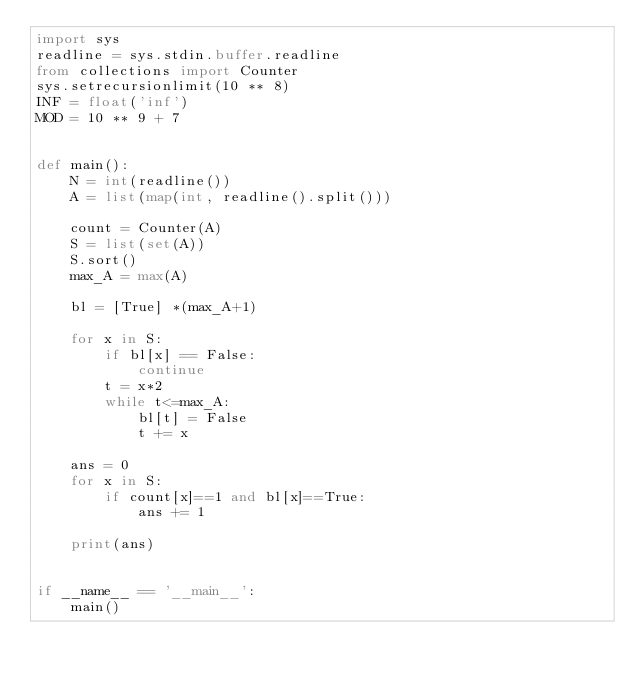<code> <loc_0><loc_0><loc_500><loc_500><_Python_>import sys
readline = sys.stdin.buffer.readline
from collections import Counter
sys.setrecursionlimit(10 ** 8)
INF = float('inf')
MOD = 10 ** 9 + 7


def main():
    N = int(readline())
    A = list(map(int, readline().split()))

    count = Counter(A)
    S = list(set(A))
    S.sort()
    max_A = max(A)

    bl = [True] *(max_A+1)

    for x in S:
        if bl[x] == False:
            continue
        t = x*2
        while t<=max_A:
            bl[t] = False
            t += x

    ans = 0
    for x in S:
        if count[x]==1 and bl[x]==True:
            ans += 1

    print(ans)


if __name__ == '__main__':
    main()
</code> 